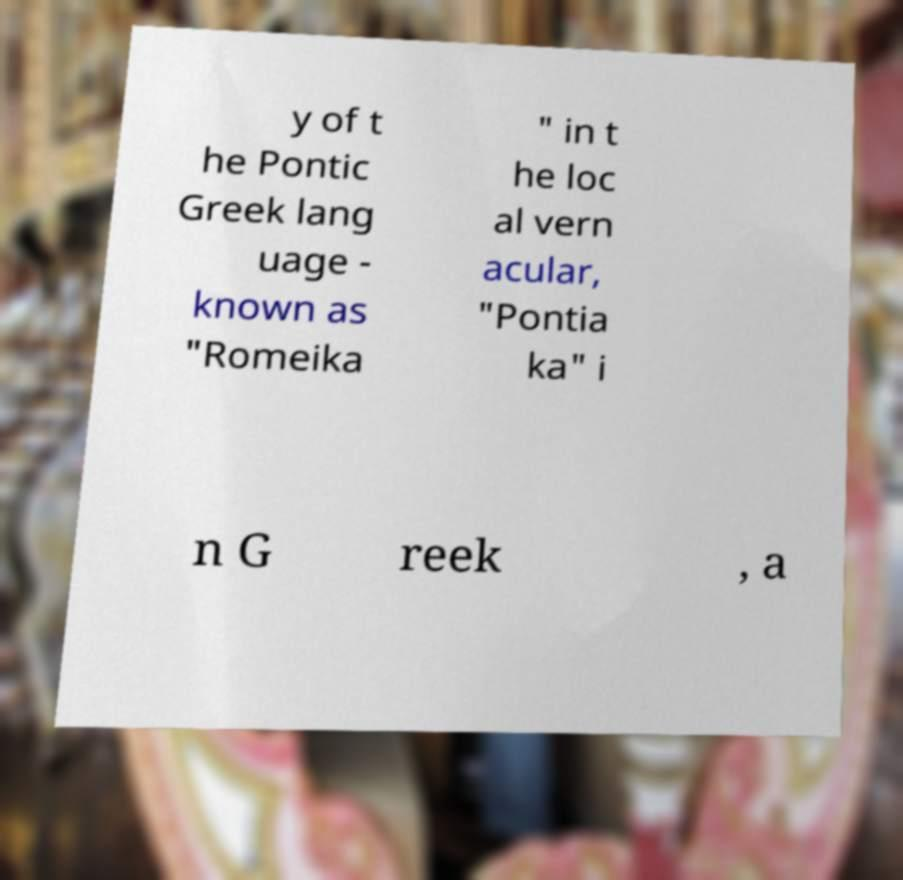Can you read and provide the text displayed in the image?This photo seems to have some interesting text. Can you extract and type it out for me? y of t he Pontic Greek lang uage - known as "Romeika " in t he loc al vern acular, "Pontia ka" i n G reek , a 